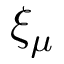Convert formula to latex. <formula><loc_0><loc_0><loc_500><loc_500>\xi _ { \mu }</formula> 